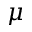Convert formula to latex. <formula><loc_0><loc_0><loc_500><loc_500>\mu</formula> 